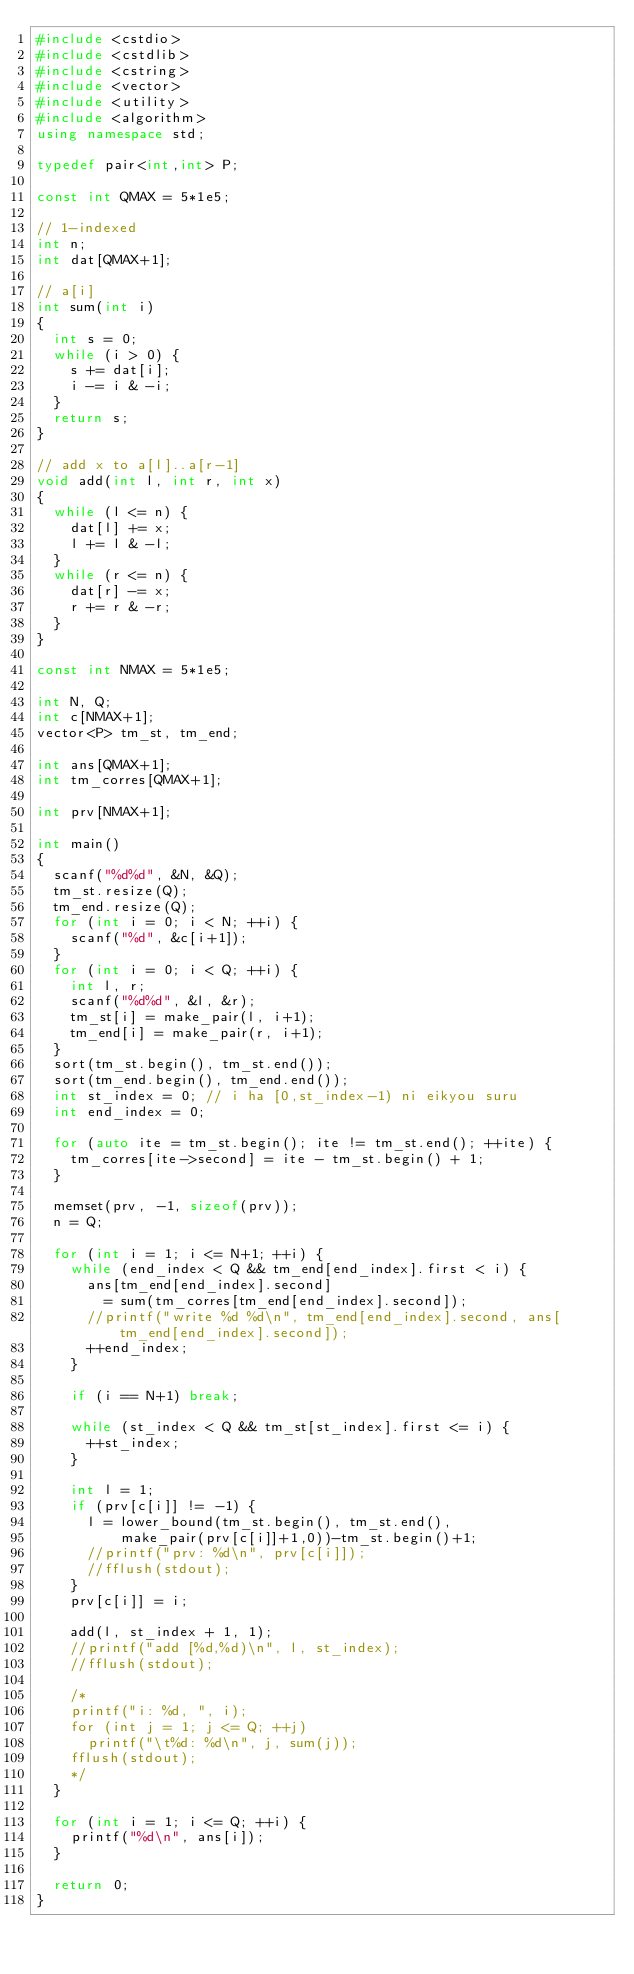<code> <loc_0><loc_0><loc_500><loc_500><_C++_>#include <cstdio>
#include <cstdlib>
#include <cstring>
#include <vector>
#include <utility>
#include <algorithm>
using namespace std;

typedef pair<int,int> P;

const int QMAX = 5*1e5;

// 1-indexed
int n;
int dat[QMAX+1];

// a[i]
int sum(int i)
{
	int s = 0;
	while (i > 0) {
		s += dat[i];
		i -= i & -i;
	}
	return s;
}

// add x to a[l]..a[r-1]
void add(int l, int r, int x)
{
	while (l <= n) {
		dat[l] += x;
		l += l & -l;
	}
	while (r <= n) {
		dat[r] -= x;
		r += r & -r;
	}
}

const int NMAX = 5*1e5;

int N, Q;
int c[NMAX+1];
vector<P> tm_st, tm_end;

int ans[QMAX+1];
int tm_corres[QMAX+1];

int prv[NMAX+1];

int main()
{
	scanf("%d%d", &N, &Q);
	tm_st.resize(Q);
	tm_end.resize(Q);
	for (int i = 0; i < N; ++i) {
		scanf("%d", &c[i+1]);
	}
	for (int i = 0; i < Q; ++i) {
		int l, r;
		scanf("%d%d", &l, &r);
		tm_st[i] = make_pair(l, i+1);
		tm_end[i] = make_pair(r, i+1);
	}
	sort(tm_st.begin(), tm_st.end());
	sort(tm_end.begin(), tm_end.end());
	int st_index = 0; // i ha [0,st_index-1) ni eikyou suru
	int end_index = 0;

	for (auto ite = tm_st.begin(); ite != tm_st.end(); ++ite) {
		tm_corres[ite->second] = ite - tm_st.begin() + 1;
	}

	memset(prv, -1, sizeof(prv));
	n = Q;

	for (int i = 1; i <= N+1; ++i) {
		while (end_index < Q && tm_end[end_index].first < i) {
			ans[tm_end[end_index].second]
				= sum(tm_corres[tm_end[end_index].second]);
			//printf("write %d %d\n", tm_end[end_index].second, ans[tm_end[end_index].second]);
			++end_index;
		}

		if (i == N+1) break;

		while (st_index < Q && tm_st[st_index].first <= i) {
			++st_index;
		}

		int l = 1;
		if (prv[c[i]] != -1) {
			l = lower_bound(tm_st.begin(), tm_st.end(),
					make_pair(prv[c[i]]+1,0))-tm_st.begin()+1;
			//printf("prv: %d\n", prv[c[i]]);
			//fflush(stdout);
		}
		prv[c[i]] = i;

		add(l, st_index + 1, 1);
		//printf("add [%d,%d)\n", l, st_index);
		//fflush(stdout);

		/*
		printf("i: %d, ", i);
		for (int j = 1; j <= Q; ++j)
			printf("\t%d: %d\n", j, sum(j));
		fflush(stdout);
		*/
	}

	for (int i = 1; i <= Q; ++i) {
		printf("%d\n", ans[i]);
	}

	return 0;
}

</code> 